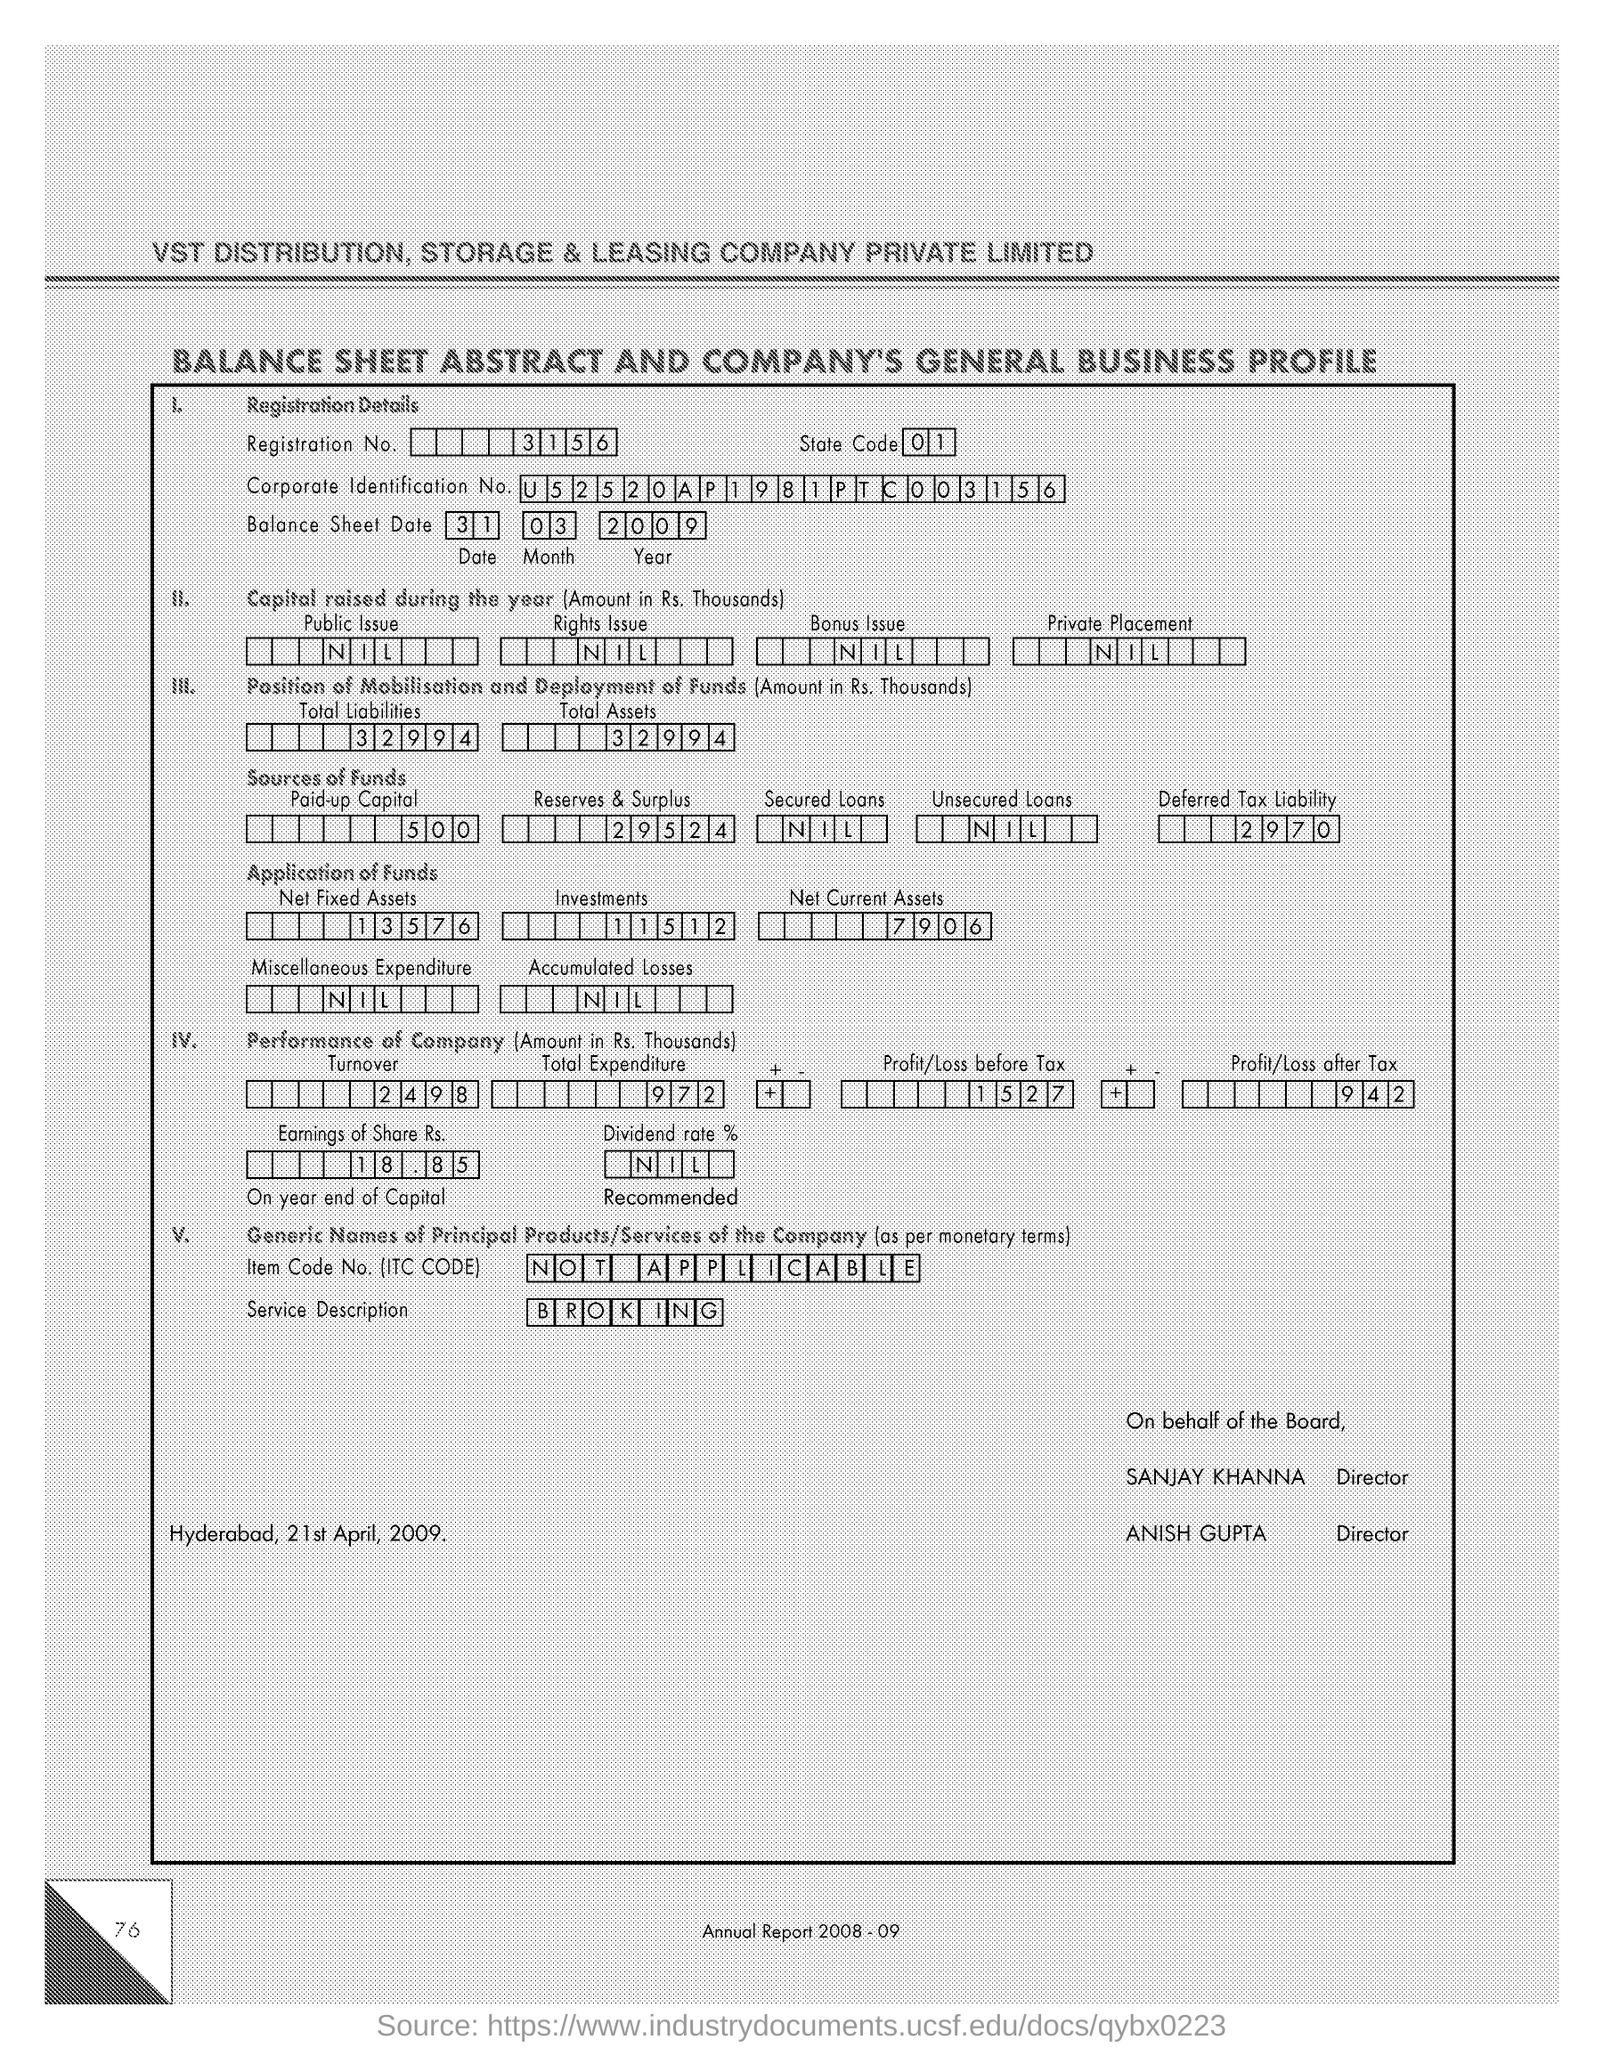What is the Registration Number ?
Provide a short and direct response. 3156. What is written in the Unsecured loans Field ?
Give a very brief answer. NIL. What is the Corporate Identification Number ?
Offer a very short reply. U52520AP1981PTC003156. What is written in the Service Description field ?
Make the answer very short. Broking. How much Profit/Loss after tax ?
Give a very brief answer. 942. What is the Item Code Number ?
Keep it short and to the point. Not Applicable. What is written in the Dividend rate field ?
Make the answer very short. NIL. 